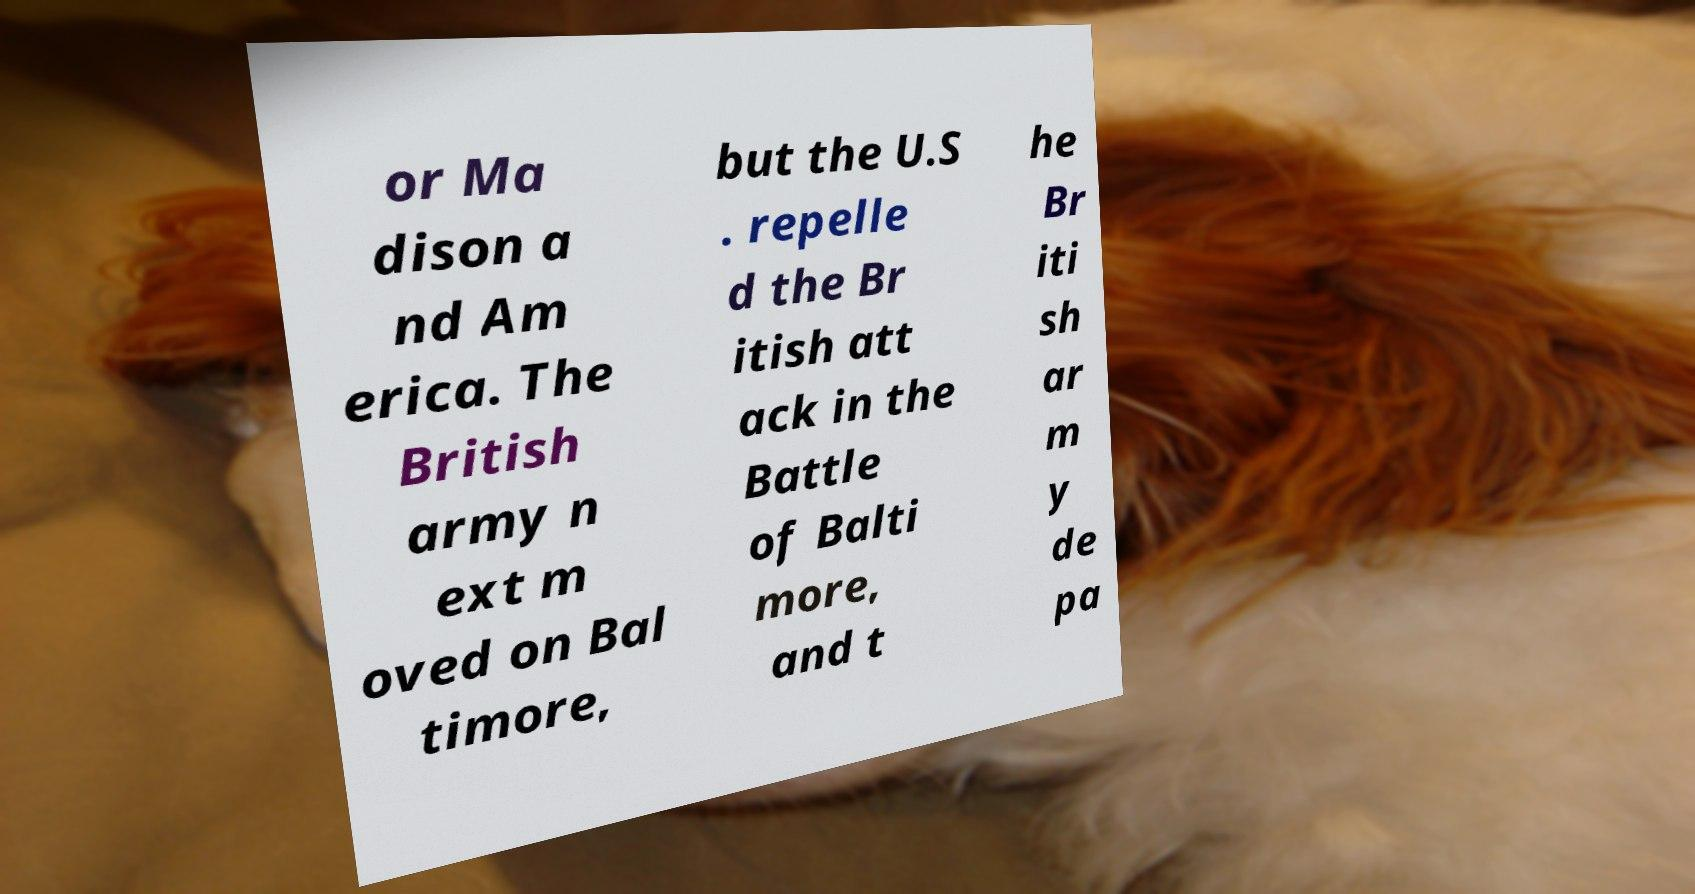Could you extract and type out the text from this image? or Ma dison a nd Am erica. The British army n ext m oved on Bal timore, but the U.S . repelle d the Br itish att ack in the Battle of Balti more, and t he Br iti sh ar m y de pa 